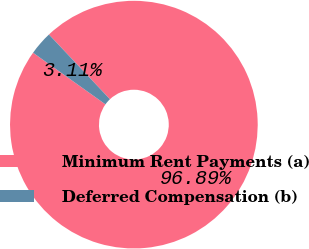Convert chart. <chart><loc_0><loc_0><loc_500><loc_500><pie_chart><fcel>Minimum Rent Payments (a)<fcel>Deferred Compensation (b)<nl><fcel>96.89%<fcel>3.11%<nl></chart> 